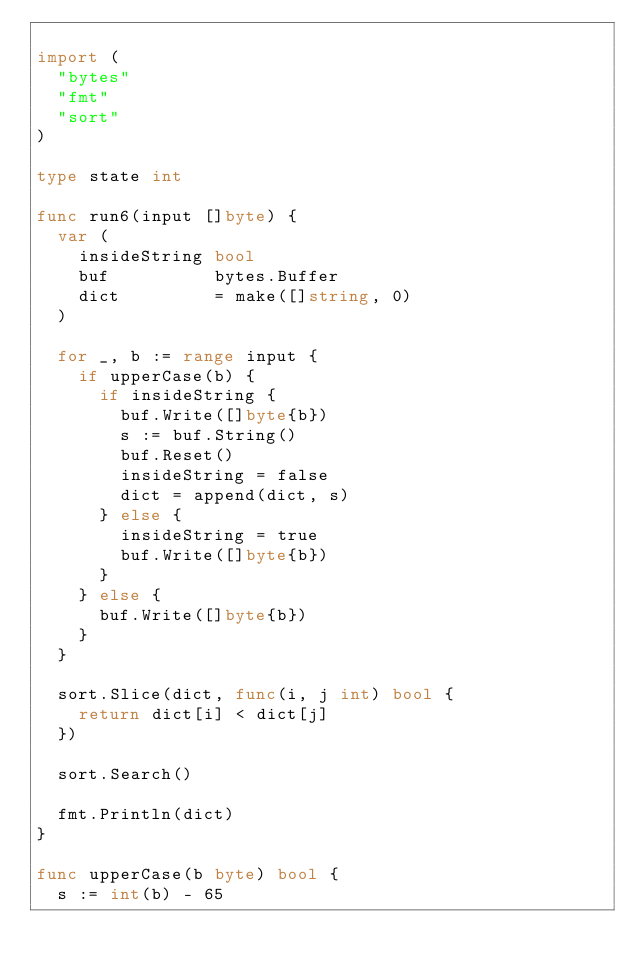<code> <loc_0><loc_0><loc_500><loc_500><_Go_>
import (
	"bytes"
	"fmt"
	"sort"
)

type state int

func run6(input []byte) {
	var (
		insideString bool
		buf          bytes.Buffer
		dict         = make([]string, 0)
	)

	for _, b := range input {
		if upperCase(b) {
			if insideString {
				buf.Write([]byte{b})
				s := buf.String()
				buf.Reset()
				insideString = false
				dict = append(dict, s)
			} else {
				insideString = true
				buf.Write([]byte{b})
			}
		} else {
			buf.Write([]byte{b})
		}
	}

	sort.Slice(dict, func(i, j int) bool {
		return dict[i] < dict[j]
	})

	sort.Search()

	fmt.Println(dict)
}

func upperCase(b byte) bool {
	s := int(b) - 65</code> 